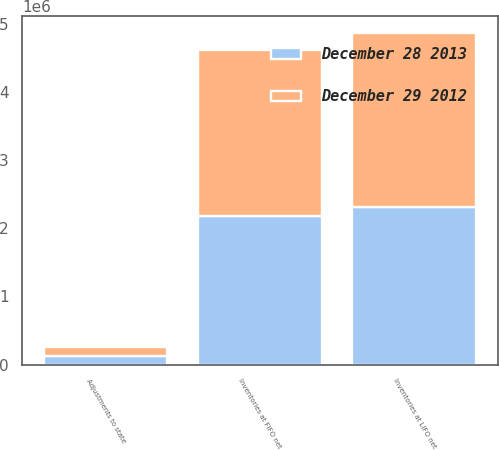Convert chart to OTSL. <chart><loc_0><loc_0><loc_500><loc_500><stacked_bar_chart><ecel><fcel>Inventories at FIFO net<fcel>Adjustments to state<fcel>Inventories at LIFO net<nl><fcel>December 29 2012<fcel>2.4248e+06<fcel>131762<fcel>2.55656e+06<nl><fcel>December 28 2013<fcel>2.18242e+06<fcel>126190<fcel>2.30861e+06<nl></chart> 